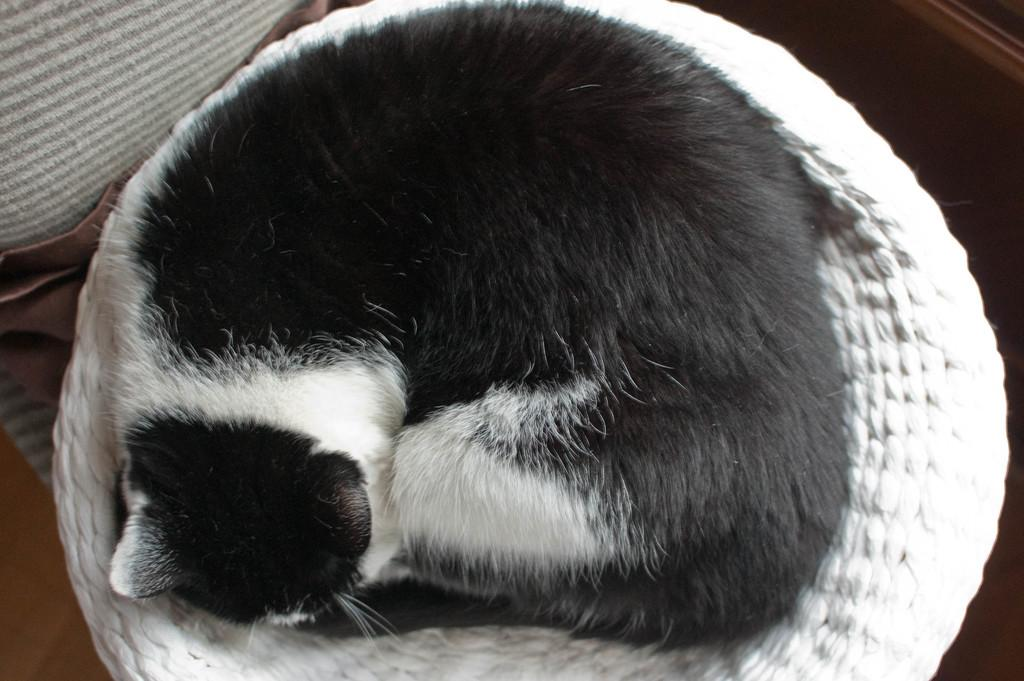What type of animal is in the image? There is a cat in the image. What colors can be seen on the cat? The cat is black and white in color. Where is the cat located in the image? The cat is sitting on a chair. How many girls are playing on the playground in the image? There is no playground or girls present in the image; it features a cat sitting on a chair. 